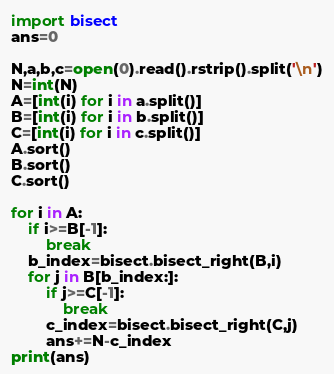<code> <loc_0><loc_0><loc_500><loc_500><_Python_>import bisect
ans=0

N,a,b,c=open(0).read().rstrip().split('\n')
N=int(N)
A=[int(i) for i in a.split()]
B=[int(i) for i in b.split()]
C=[int(i) for i in c.split()]
A.sort()
B.sort()
C.sort()

for i in A:
    if i>=B[-1]:
        break
    b_index=bisect.bisect_right(B,i)
    for j in B[b_index:]:
        if j>=C[-1]:
            break
        c_index=bisect.bisect_right(C,j)
        ans+=N-c_index
print(ans)</code> 